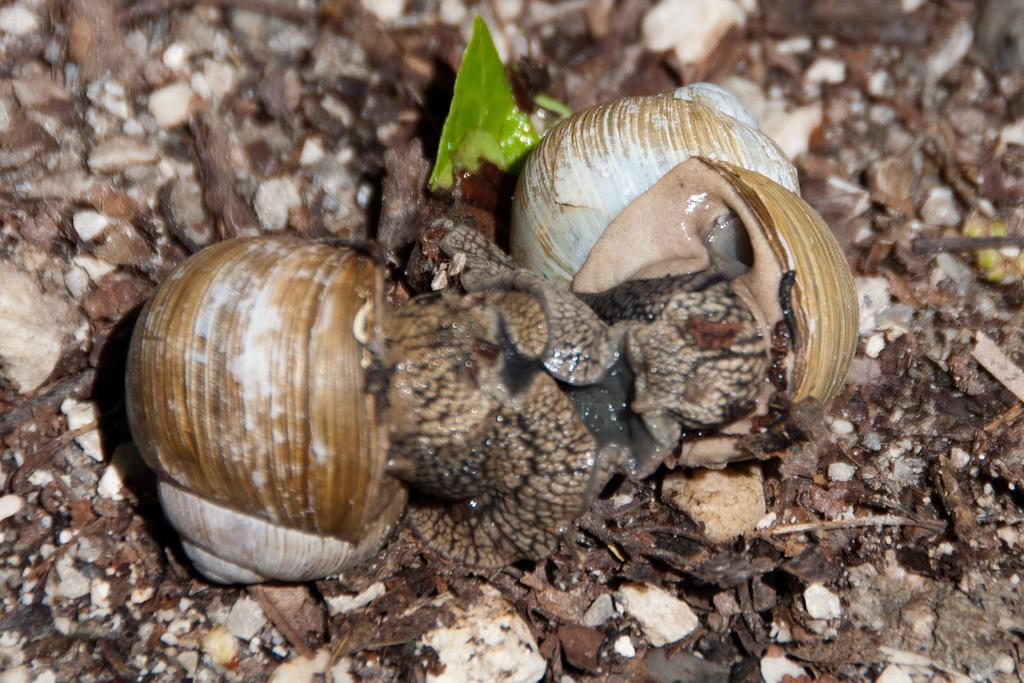What type of animals can be seen in the image? There are snails in the image. What type of plant is present in the image? There is a green leaf in the image. What type of objects are on the ground in the image? There are stones and wooden pieces on the ground in the image. What type of medical advice is being given in the image? There is no doctor or medical advice present in the image; it features snails, a green leaf, stones, and wooden pieces. 